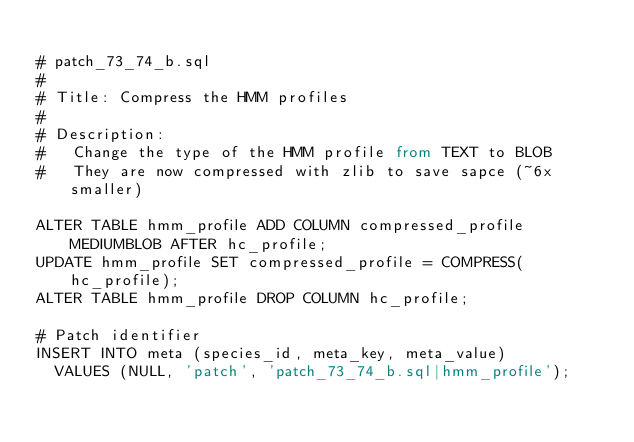Convert code to text. <code><loc_0><loc_0><loc_500><loc_500><_SQL_>
# patch_73_74_b.sql
#
# Title: Compress the HMM profiles
#
# Description:
#   Change the type of the HMM profile from TEXT to BLOB
#   They are now compressed with zlib to save sapce (~6x smaller)

ALTER TABLE hmm_profile ADD COLUMN compressed_profile MEDIUMBLOB AFTER hc_profile;
UPDATE hmm_profile SET compressed_profile = COMPRESS(hc_profile);
ALTER TABLE hmm_profile DROP COLUMN hc_profile;

# Patch identifier
INSERT INTO meta (species_id, meta_key, meta_value)
  VALUES (NULL, 'patch', 'patch_73_74_b.sql|hmm_profile');
</code> 